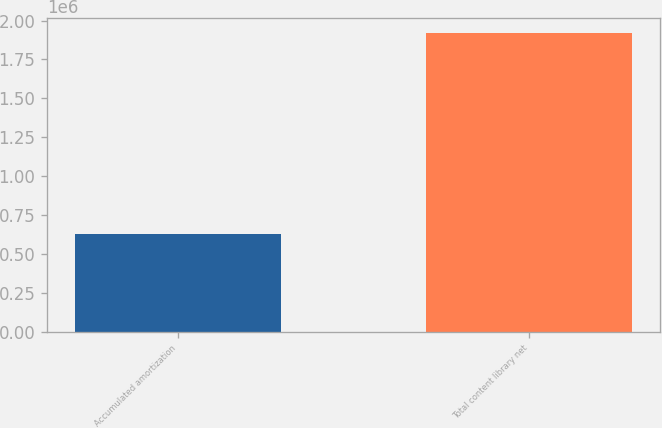<chart> <loc_0><loc_0><loc_500><loc_500><bar_chart><fcel>Accumulated amortization<fcel>Total content library net<nl><fcel>632270<fcel>1.92001e+06<nl></chart> 